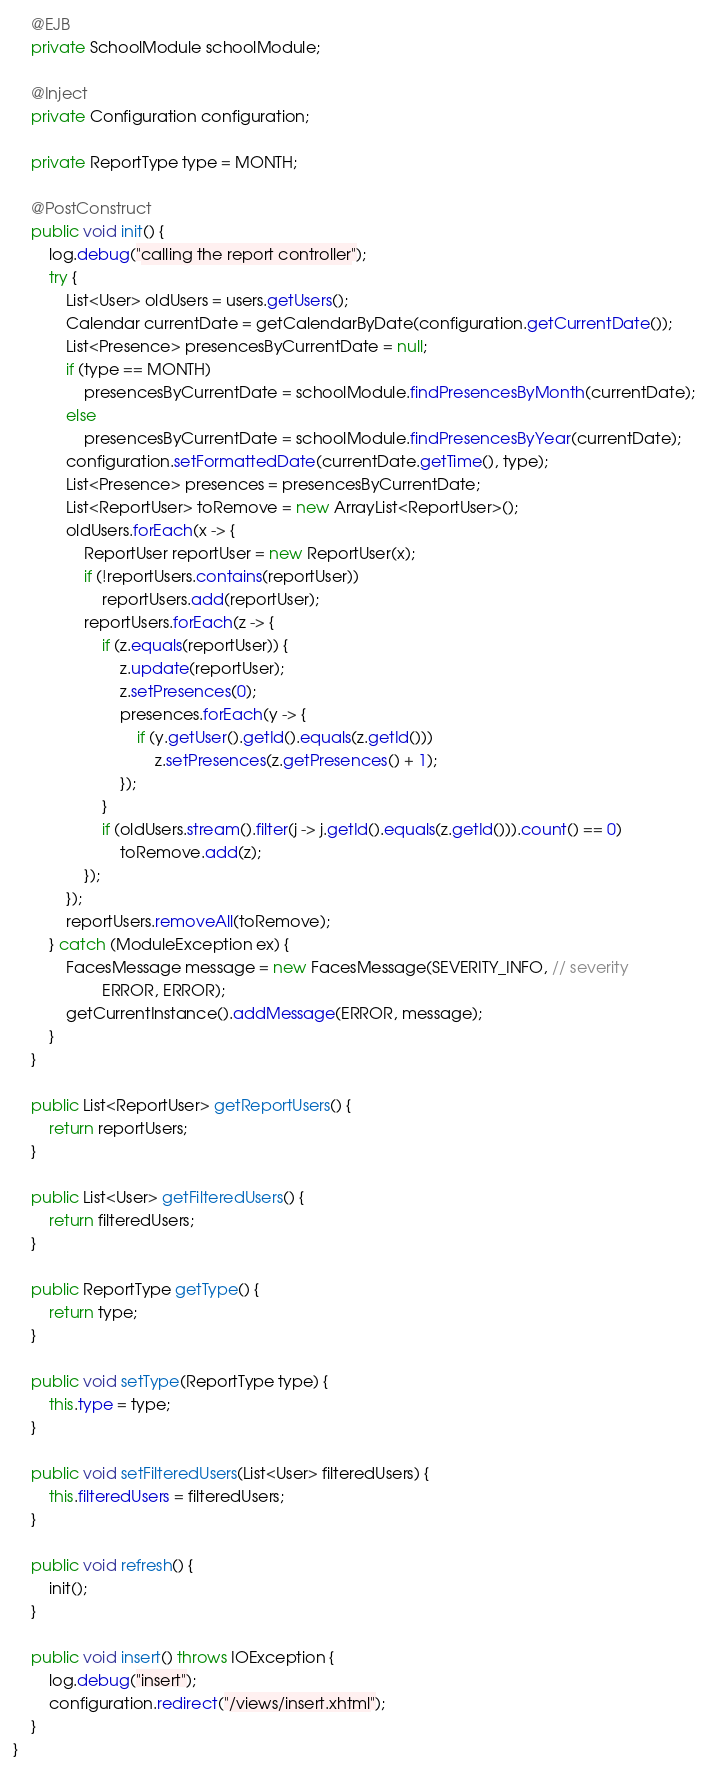Convert code to text. <code><loc_0><loc_0><loc_500><loc_500><_Java_>
	@EJB
	private SchoolModule schoolModule;

	@Inject
	private Configuration configuration;

	private ReportType type = MONTH;

	@PostConstruct
	public void init() {
		log.debug("calling the report controller");
		try {
			List<User> oldUsers = users.getUsers();
			Calendar currentDate = getCalendarByDate(configuration.getCurrentDate());
			List<Presence> presencesByCurrentDate = null;
			if (type == MONTH)
				presencesByCurrentDate = schoolModule.findPresencesByMonth(currentDate);
			else
				presencesByCurrentDate = schoolModule.findPresencesByYear(currentDate);
			configuration.setFormattedDate(currentDate.getTime(), type);
			List<Presence> presences = presencesByCurrentDate;
			List<ReportUser> toRemove = new ArrayList<ReportUser>();
			oldUsers.forEach(x -> {
				ReportUser reportUser = new ReportUser(x);
				if (!reportUsers.contains(reportUser))
					reportUsers.add(reportUser);
				reportUsers.forEach(z -> {
					if (z.equals(reportUser)) {
						z.update(reportUser);
						z.setPresences(0);
						presences.forEach(y -> {
							if (y.getUser().getId().equals(z.getId()))
								z.setPresences(z.getPresences() + 1);
						});
					}
					if (oldUsers.stream().filter(j -> j.getId().equals(z.getId())).count() == 0)
						toRemove.add(z);
				});
			});
			reportUsers.removeAll(toRemove);
		} catch (ModuleException ex) {
			FacesMessage message = new FacesMessage(SEVERITY_INFO, // severity
					ERROR, ERROR);
			getCurrentInstance().addMessage(ERROR, message);
		}
	}

	public List<ReportUser> getReportUsers() {
		return reportUsers;
	}

	public List<User> getFilteredUsers() {
		return filteredUsers;
	}

	public ReportType getType() {
		return type;
	}

	public void setType(ReportType type) {
		this.type = type;
	}

	public void setFilteredUsers(List<User> filteredUsers) {
		this.filteredUsers = filteredUsers;
	}

	public void refresh() {
		init();
	}

	public void insert() throws IOException {
		log.debug("insert");
		configuration.redirect("/views/insert.xhtml");
	}
}
</code> 